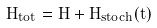<formula> <loc_0><loc_0><loc_500><loc_500>H _ { t o t } = H + H _ { s t o c h } ( t )</formula> 